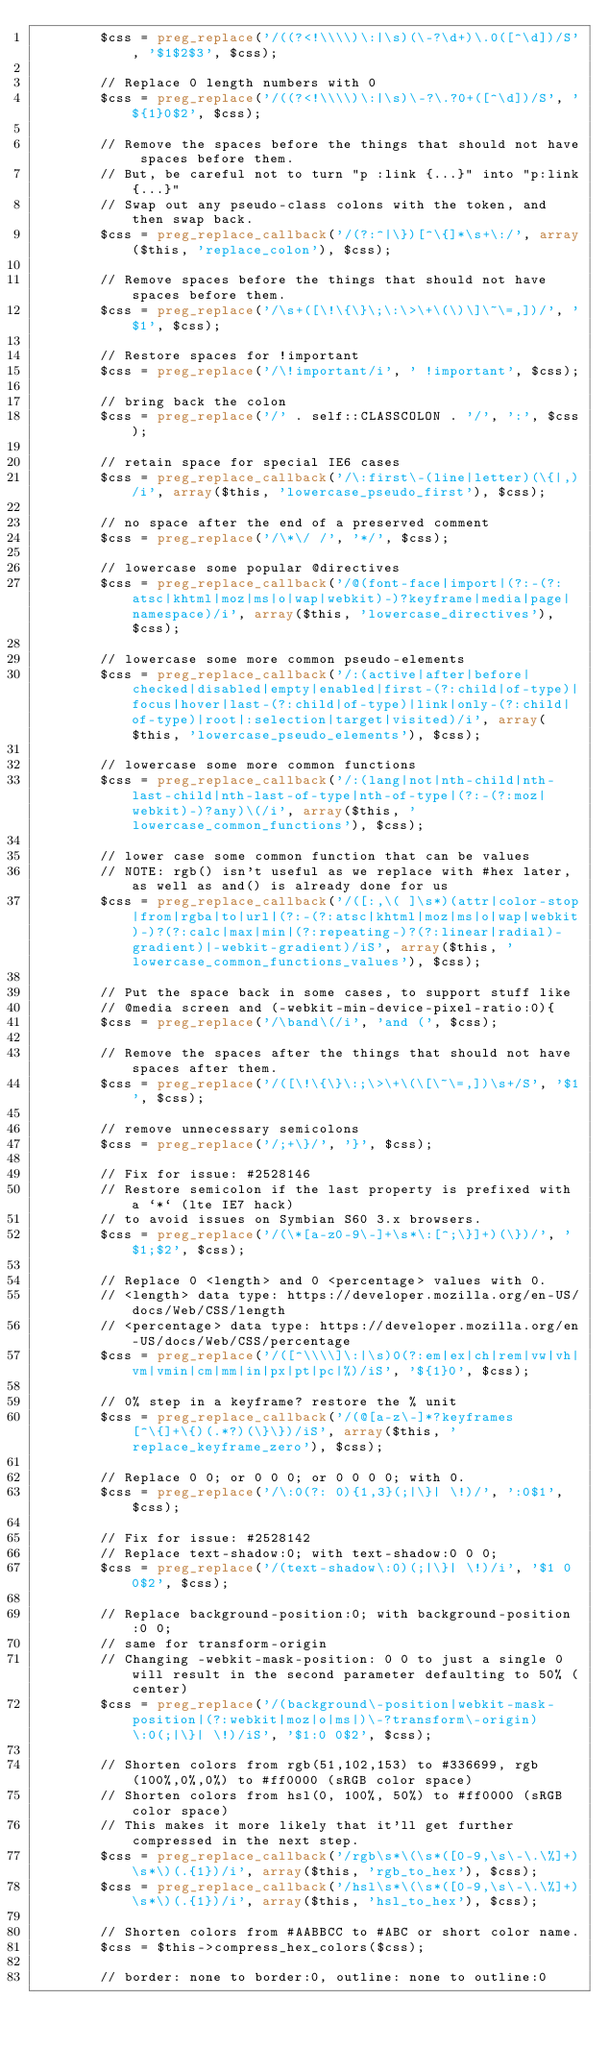<code> <loc_0><loc_0><loc_500><loc_500><_PHP_>        $css = preg_replace('/((?<!\\\\)\:|\s)(\-?\d+)\.0([^\d])/S', '$1$2$3', $css);

        // Replace 0 length numbers with 0
        $css = preg_replace('/((?<!\\\\)\:|\s)\-?\.?0+([^\d])/S', '${1}0$2', $css);

        // Remove the spaces before the things that should not have spaces before them.
        // But, be careful not to turn "p :link {...}" into "p:link{...}"
        // Swap out any pseudo-class colons with the token, and then swap back.
        $css = preg_replace_callback('/(?:^|\})[^\{]*\s+\:/', array($this, 'replace_colon'), $css);

        // Remove spaces before the things that should not have spaces before them.
        $css = preg_replace('/\s+([\!\{\}\;\:\>\+\(\)\]\~\=,])/', '$1', $css);

        // Restore spaces for !important
        $css = preg_replace('/\!important/i', ' !important', $css);

        // bring back the colon
        $css = preg_replace('/' . self::CLASSCOLON . '/', ':', $css);

        // retain space for special IE6 cases
        $css = preg_replace_callback('/\:first\-(line|letter)(\{|,)/i', array($this, 'lowercase_pseudo_first'), $css);

        // no space after the end of a preserved comment
        $css = preg_replace('/\*\/ /', '*/', $css);

        // lowercase some popular @directives
        $css = preg_replace_callback('/@(font-face|import|(?:-(?:atsc|khtml|moz|ms|o|wap|webkit)-)?keyframe|media|page|namespace)/i', array($this, 'lowercase_directives'), $css);

        // lowercase some more common pseudo-elements
        $css = preg_replace_callback('/:(active|after|before|checked|disabled|empty|enabled|first-(?:child|of-type)|focus|hover|last-(?:child|of-type)|link|only-(?:child|of-type)|root|:selection|target|visited)/i', array($this, 'lowercase_pseudo_elements'), $css);

        // lowercase some more common functions
        $css = preg_replace_callback('/:(lang|not|nth-child|nth-last-child|nth-last-of-type|nth-of-type|(?:-(?:moz|webkit)-)?any)\(/i', array($this, 'lowercase_common_functions'), $css);

        // lower case some common function that can be values
        // NOTE: rgb() isn't useful as we replace with #hex later, as well as and() is already done for us
        $css = preg_replace_callback('/([:,\( ]\s*)(attr|color-stop|from|rgba|to|url|(?:-(?:atsc|khtml|moz|ms|o|wap|webkit)-)?(?:calc|max|min|(?:repeating-)?(?:linear|radial)-gradient)|-webkit-gradient)/iS', array($this, 'lowercase_common_functions_values'), $css);

        // Put the space back in some cases, to support stuff like
        // @media screen and (-webkit-min-device-pixel-ratio:0){
        $css = preg_replace('/\band\(/i', 'and (', $css);

        // Remove the spaces after the things that should not have spaces after them.
        $css = preg_replace('/([\!\{\}\:;\>\+\(\[\~\=,])\s+/S', '$1', $css);

        // remove unnecessary semicolons
        $css = preg_replace('/;+\}/', '}', $css);

        // Fix for issue: #2528146
        // Restore semicolon if the last property is prefixed with a `*` (lte IE7 hack)
        // to avoid issues on Symbian S60 3.x browsers.
        $css = preg_replace('/(\*[a-z0-9\-]+\s*\:[^;\}]+)(\})/', '$1;$2', $css);

        // Replace 0 <length> and 0 <percentage> values with 0.
        // <length> data type: https://developer.mozilla.org/en-US/docs/Web/CSS/length
        // <percentage> data type: https://developer.mozilla.org/en-US/docs/Web/CSS/percentage
        $css = preg_replace('/([^\\\\]\:|\s)0(?:em|ex|ch|rem|vw|vh|vm|vmin|cm|mm|in|px|pt|pc|%)/iS', '${1}0', $css);

		// 0% step in a keyframe? restore the % unit
		$css = preg_replace_callback('/(@[a-z\-]*?keyframes[^\{]+\{)(.*?)(\}\})/iS', array($this, 'replace_keyframe_zero'), $css);

        // Replace 0 0; or 0 0 0; or 0 0 0 0; with 0.
        $css = preg_replace('/\:0(?: 0){1,3}(;|\}| \!)/', ':0$1', $css);

        // Fix for issue: #2528142
        // Replace text-shadow:0; with text-shadow:0 0 0;
        $css = preg_replace('/(text-shadow\:0)(;|\}| \!)/i', '$1 0 0$2', $css);

        // Replace background-position:0; with background-position:0 0;
        // same for transform-origin
        // Changing -webkit-mask-position: 0 0 to just a single 0 will result in the second parameter defaulting to 50% (center)
        $css = preg_replace('/(background\-position|webkit-mask-position|(?:webkit|moz|o|ms|)\-?transform\-origin)\:0(;|\}| \!)/iS', '$1:0 0$2', $css);

        // Shorten colors from rgb(51,102,153) to #336699, rgb(100%,0%,0%) to #ff0000 (sRGB color space)
        // Shorten colors from hsl(0, 100%, 50%) to #ff0000 (sRGB color space)
        // This makes it more likely that it'll get further compressed in the next step.
        $css = preg_replace_callback('/rgb\s*\(\s*([0-9,\s\-\.\%]+)\s*\)(.{1})/i', array($this, 'rgb_to_hex'), $css);
        $css = preg_replace_callback('/hsl\s*\(\s*([0-9,\s\-\.\%]+)\s*\)(.{1})/i', array($this, 'hsl_to_hex'), $css);

        // Shorten colors from #AABBCC to #ABC or short color name.
        $css = $this->compress_hex_colors($css);

        // border: none to border:0, outline: none to outline:0</code> 